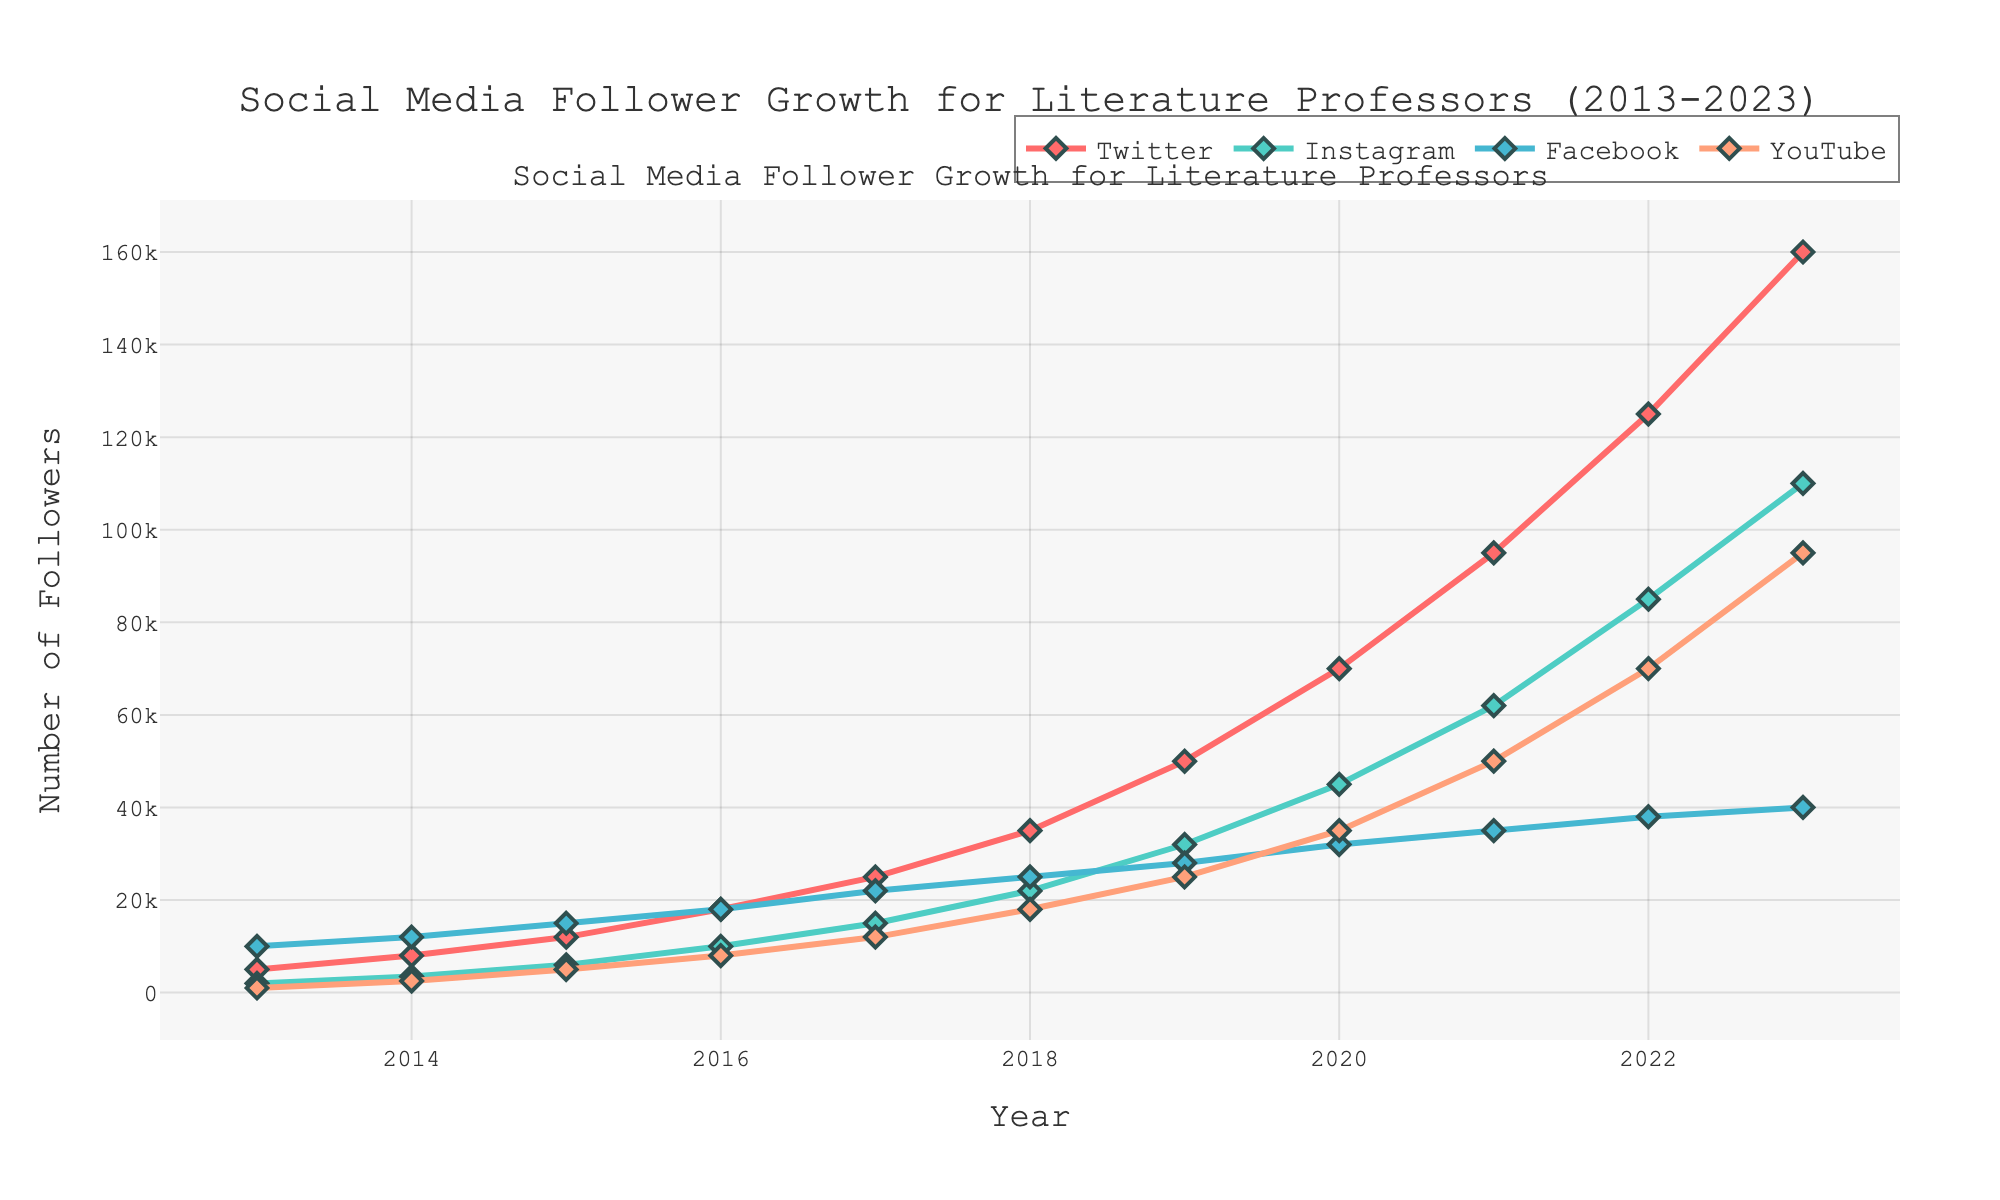Which social media platform had the highest number of followers in 2023? The figure shows the number of followers for each platform in the year 2023. Twitter has the highest value of 160,000 followers.
Answer: Twitter How did Instagram followers grow from 2014 to 2015? The figure shows the follower count for Instagram in 2014 (3,500) and 2015 (6,000). To find the growth, subtract the 2014 value from the 2015 value: 6,000 - 3,500 = 2,500.
Answer: 2,500 Which platform showed the greatest relative increase in followers between 2019 and 2020? The relative increase is calculated by the difference in followers between the two years divided by the follower count in 2019. We calculate for each:
- Twitter: (70,000 - 50,000) / 50,000 = 0.4
- Instagram: (45,000 - 32,000) / 32,000 = 0.40625
- Facebook: (32,000 - 28,000) / 28,000 = 0.142857
- YouTube: (35,000 - 25,000) / 25,000 = 0.4
Instagram has the highest relative increase of 0.40625.
Answer: Instagram What was the combined number of followers on all platforms in 2020? Add the follower counts for each platform in the year 2020. Twitter (70,000) + Instagram (45,000) + Facebook (32,000) + YouTube (35,000) = 182,000.
Answer: 182,000 During which year did Twitter exceed 100,000 followers? From the chart, Twitter surpassed 100,000 followers in the year 2021, as it increased from 70,000 in 2020 to 95,000 in 2021.
Answer: 2021 Which social media platform had the slowest growth in the entire decade? By visually comparing the slopes of the lines, Facebook had the slowest growth as it starts at 10,000 in 2013 and ends at 40,000 in 2023, showing a smaller increase compared to other platforms.
Answer: Facebook By how much did YouTube followers increase between 2016 and 2022? Subtract the number of YouTube followers in 2016 (8,000) from the number in 2022 (70,000). 70,000 - 8,000 = 62,000.
Answer: 62,000 How does the follower growth trend on Twitter compare with Facebook from 2013 to 2023? Twitter's number of followers shows a steady steep increase each year, while Facebook shows a more gradual increase and the slope is less steep. This means Twitter's growth rate was much higher compared to Facebook.
Answer: Twitter's growth was much higher When did Instagram surpass Facebook in follower count? The figure displays that Instagram surpassed Facebook between 2016 and 2017. This is evident as Instagram's line crosses above Facebook's line within this period.
Answer: Between 2016 and 2017 